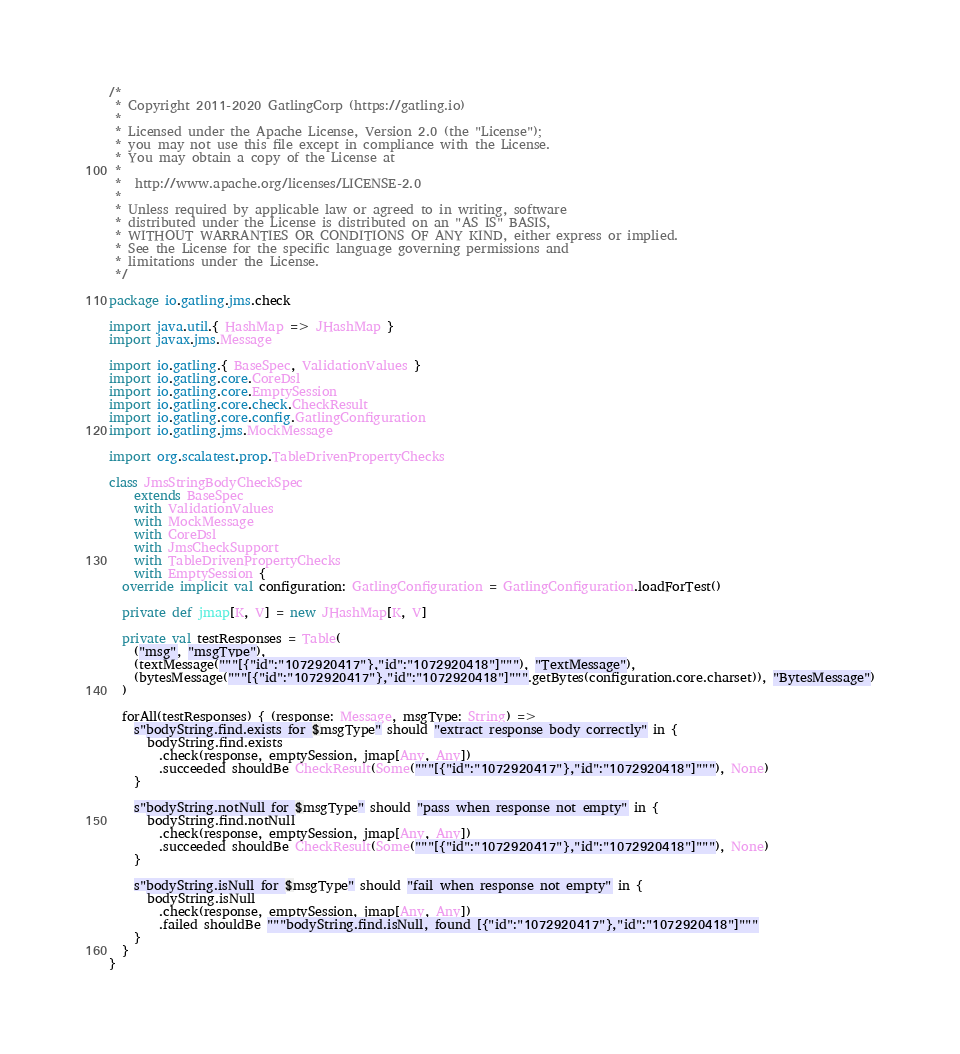Convert code to text. <code><loc_0><loc_0><loc_500><loc_500><_Scala_>/*
 * Copyright 2011-2020 GatlingCorp (https://gatling.io)
 *
 * Licensed under the Apache License, Version 2.0 (the "License");
 * you may not use this file except in compliance with the License.
 * You may obtain a copy of the License at
 *
 *  http://www.apache.org/licenses/LICENSE-2.0
 *
 * Unless required by applicable law or agreed to in writing, software
 * distributed under the License is distributed on an "AS IS" BASIS,
 * WITHOUT WARRANTIES OR CONDITIONS OF ANY KIND, either express or implied.
 * See the License for the specific language governing permissions and
 * limitations under the License.
 */

package io.gatling.jms.check

import java.util.{ HashMap => JHashMap }
import javax.jms.Message

import io.gatling.{ BaseSpec, ValidationValues }
import io.gatling.core.CoreDsl
import io.gatling.core.EmptySession
import io.gatling.core.check.CheckResult
import io.gatling.core.config.GatlingConfiguration
import io.gatling.jms.MockMessage

import org.scalatest.prop.TableDrivenPropertyChecks

class JmsStringBodyCheckSpec
    extends BaseSpec
    with ValidationValues
    with MockMessage
    with CoreDsl
    with JmsCheckSupport
    with TableDrivenPropertyChecks
    with EmptySession {
  override implicit val configuration: GatlingConfiguration = GatlingConfiguration.loadForTest()

  private def jmap[K, V] = new JHashMap[K, V]

  private val testResponses = Table(
    ("msg", "msgType"),
    (textMessage("""[{"id":"1072920417"},"id":"1072920418"]"""), "TextMessage"),
    (bytesMessage("""[{"id":"1072920417"},"id":"1072920418"]""".getBytes(configuration.core.charset)), "BytesMessage")
  )

  forAll(testResponses) { (response: Message, msgType: String) =>
    s"bodyString.find.exists for $msgType" should "extract response body correctly" in {
      bodyString.find.exists
        .check(response, emptySession, jmap[Any, Any])
        .succeeded shouldBe CheckResult(Some("""[{"id":"1072920417"},"id":"1072920418"]"""), None)
    }

    s"bodyString.notNull for $msgType" should "pass when response not empty" in {
      bodyString.find.notNull
        .check(response, emptySession, jmap[Any, Any])
        .succeeded shouldBe CheckResult(Some("""[{"id":"1072920417"},"id":"1072920418"]"""), None)
    }

    s"bodyString.isNull for $msgType" should "fail when response not empty" in {
      bodyString.isNull
        .check(response, emptySession, jmap[Any, Any])
        .failed shouldBe """bodyString.find.isNull, found [{"id":"1072920417"},"id":"1072920418"]"""
    }
  }
}
</code> 